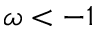Convert formula to latex. <formula><loc_0><loc_0><loc_500><loc_500>\omega < - 1</formula> 